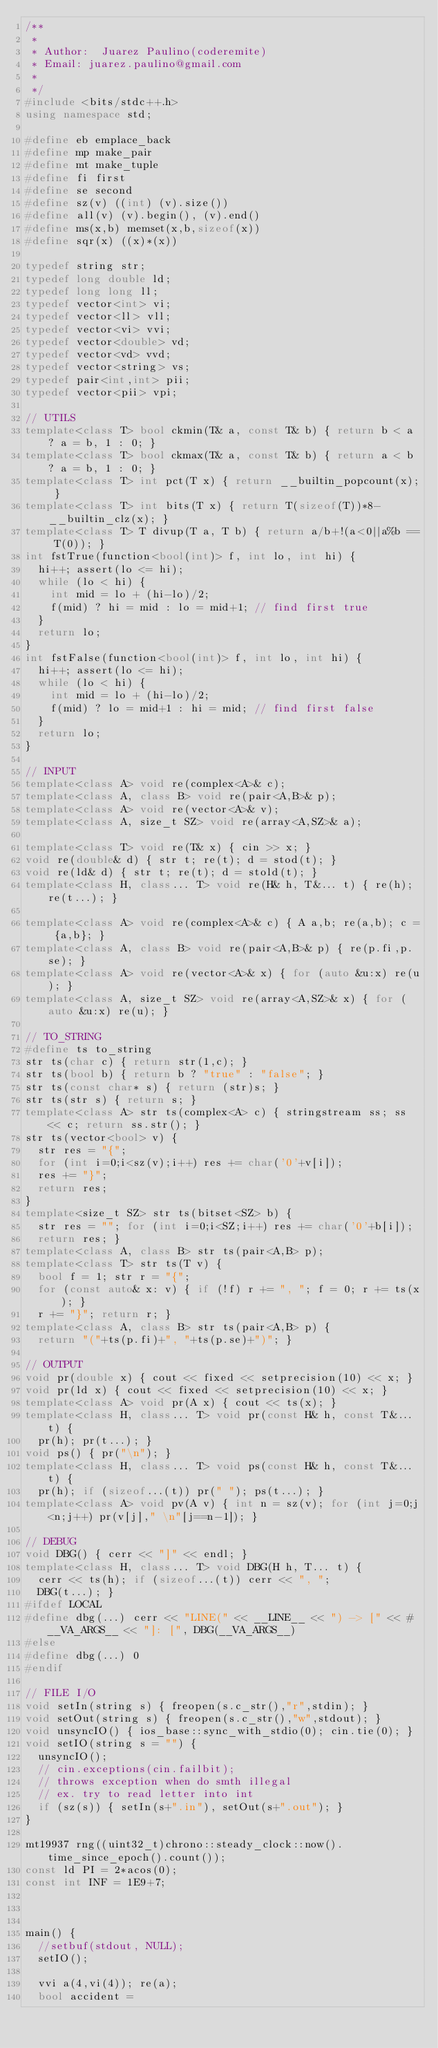Convert code to text. <code><loc_0><loc_0><loc_500><loc_500><_C++_>/**
 *
 * Author:  Juarez Paulino(coderemite)
 * Email: juarez.paulino@gmail.com
 *
 */
#include <bits/stdc++.h>
using namespace std;

#define eb emplace_back
#define mp make_pair
#define mt make_tuple
#define fi first
#define se second
#define sz(v) ((int) (v).size())
#define all(v) (v).begin(), (v).end()
#define ms(x,b) memset(x,b,sizeof(x))
#define sqr(x) ((x)*(x))

typedef string str;
typedef long double ld;
typedef long long ll;
typedef vector<int> vi;
typedef vector<ll> vll;
typedef vector<vi> vvi;
typedef vector<double> vd;
typedef vector<vd> vvd;
typedef vector<string> vs;
typedef pair<int,int> pii;
typedef vector<pii> vpi;

// UTILS
template<class T> bool ckmin(T& a, const T& b) { return b < a ? a = b, 1 : 0; }
template<class T> bool ckmax(T& a, const T& b) { return a < b ? a = b, 1 : 0; } 
template<class T> int pct(T x) { return __builtin_popcount(x); }
template<class T> int bits(T x) { return T(sizeof(T))*8-__builtin_clz(x); }
template<class T> T divup(T a, T b) { return a/b+!(a<0||a%b == T(0)); }
int fstTrue(function<bool(int)> f, int lo, int hi) {
  hi++; assert(lo <= hi);
  while (lo < hi) {  
    int mid = lo + (hi-lo)/2; 
    f(mid) ? hi = mid : lo = mid+1; // find first true
  }
  return lo;
}
int fstFalse(function<bool(int)> f, int lo, int hi) {
  hi++; assert(lo <= hi);
  while (lo < hi) {  
    int mid = lo + (hi-lo)/2; 
    f(mid) ? lo = mid+1 : hi = mid; // find first false
  }
  return lo;
}

// INPUT
template<class A> void re(complex<A>& c);
template<class A, class B> void re(pair<A,B>& p);
template<class A> void re(vector<A>& v);
template<class A, size_t SZ> void re(array<A,SZ>& a);
 
template<class T> void re(T& x) { cin >> x; }
void re(double& d) { str t; re(t); d = stod(t); }
void re(ld& d) { str t; re(t); d = stold(t); }
template<class H, class... T> void re(H& h, T&... t) { re(h); re(t...); }
 
template<class A> void re(complex<A>& c) { A a,b; re(a,b); c = {a,b}; }
template<class A, class B> void re(pair<A,B>& p) { re(p.fi,p.se); }
template<class A> void re(vector<A>& x) { for (auto &u:x) re(u); }
template<class A, size_t SZ> void re(array<A,SZ>& x) { for (auto &u:x) re(u); }

// TO_STRING
#define ts to_string
str ts(char c) { return str(1,c); }
str ts(bool b) { return b ? "true" : "false"; }
str ts(const char* s) { return (str)s; }
str ts(str s) { return s; }
template<class A> str ts(complex<A> c) { stringstream ss; ss << c; return ss.str(); }
str ts(vector<bool> v) { 
  str res = "{";
  for (int i=0;i<sz(v);i++) res += char('0'+v[i]);
  res += "}";
  return res;
}
template<size_t SZ> str ts(bitset<SZ> b) {
  str res = ""; for (int i=0;i<SZ;i++) res += char('0'+b[i]);
  return res; }
template<class A, class B> str ts(pair<A,B> p);
template<class T> str ts(T v) {
  bool f = 1; str r = "{";
  for (const auto& x: v) { if (!f) r += ", "; f = 0; r += ts(x); }
  r += "}"; return r; }
template<class A, class B> str ts(pair<A,B> p) {
  return "("+ts(p.fi)+", "+ts(p.se)+")"; }
 
// OUTPUT
void pr(double x) { cout << fixed << setprecision(10) << x; }
void pr(ld x) { cout << fixed << setprecision(10) << x; }
template<class A> void pr(A x) { cout << ts(x); }
template<class H, class... T> void pr(const H& h, const T&... t) { 
  pr(h); pr(t...); }
void ps() { pr("\n"); }
template<class H, class... T> void ps(const H& h, const T&... t) { 
  pr(h); if (sizeof...(t)) pr(" "); ps(t...); }
template<class A> void pv(A v) { int n = sz(v); for (int j=0;j<n;j++) pr(v[j]," \n"[j==n-1]); }
 
// DEBUG
void DBG() { cerr << "]" << endl; }
template<class H, class... T> void DBG(H h, T... t) {
  cerr << ts(h); if (sizeof...(t)) cerr << ", ";
  DBG(t...); }
#ifdef LOCAL
#define dbg(...) cerr << "LINE(" << __LINE__ << ") -> [" << #__VA_ARGS__ << "]: [", DBG(__VA_ARGS__)
#else
#define dbg(...) 0
#endif
 
// FILE I/O
void setIn(string s) { freopen(s.c_str(),"r",stdin); }
void setOut(string s) { freopen(s.c_str(),"w",stdout); }
void unsyncIO() { ios_base::sync_with_stdio(0); cin.tie(0); }
void setIO(string s = "") {
  unsyncIO();
  // cin.exceptions(cin.failbit); 
  // throws exception when do smth illegal
  // ex. try to read letter into int
  if (sz(s)) { setIn(s+".in"), setOut(s+".out"); }
}

mt19937 rng((uint32_t)chrono::steady_clock::now().time_since_epoch().count());
const ld PI = 2*acos(0);
const int INF = 1E9+7;



main() {
  //setbuf(stdout, NULL);
  setIO();

  vvi a(4,vi(4)); re(a);
  bool accident =</code> 